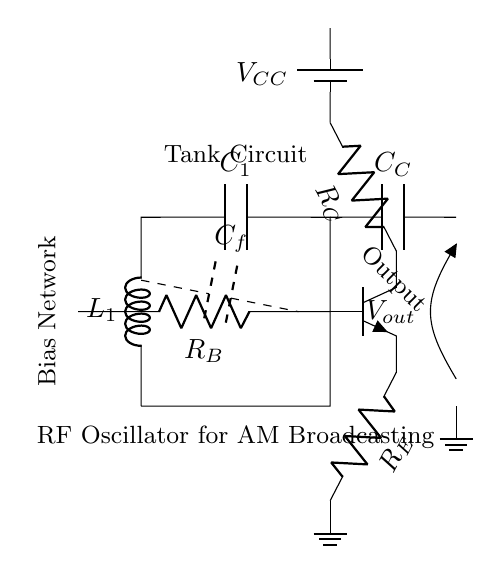What is the role of the inductor in this circuit? The inductor L1 forms part of the tank circuit, which determines the frequency of oscillation. In a resonance circuit, the inductor stores energy in its magnetic field.
Answer: Tank circuit component What is the function of the coupling capacitor C_C? The coupling capacitor C_C allows the AC signal to pass from the tank circuit to the output while blocking DC voltage. It enables signal transfer while maintaining isolation between the stages.
Answer: Signal transfer What type of transistor is used in this oscillator? The diagram displays an NPN transistor (identifiable by the symbol) used for amplification in the oscillator circuit.
Answer: NPN What are the biasing resistors labeled in the circuit? The biasing resistors are labeled R_B (base), R_C (collector), and R_E (emitter). They provide the necessary biasing required to properly operate the transistor in the active region.
Answer: R_B, R_C, R_E What is the purpose of the capacitor C_f in the circuit? Capacitor C_f provides feedback from the output to the base of the transistor, essential for sustaining the oscillations in the circuit by reinforcing the input signal.
Answer: Feedback What does V_CC represent in this circuit? V_CC represents the external power supply voltage that powers the transistor and the oscillator circuit. It ensures proper operation of the amplifier stages.
Answer: Power supply voltage What is the output voltage labeled as in the circuit? The output voltage is labeled as V_out, indicating the voltage that is available at the output of the oscillator circuit for transmission.
Answer: V_out 